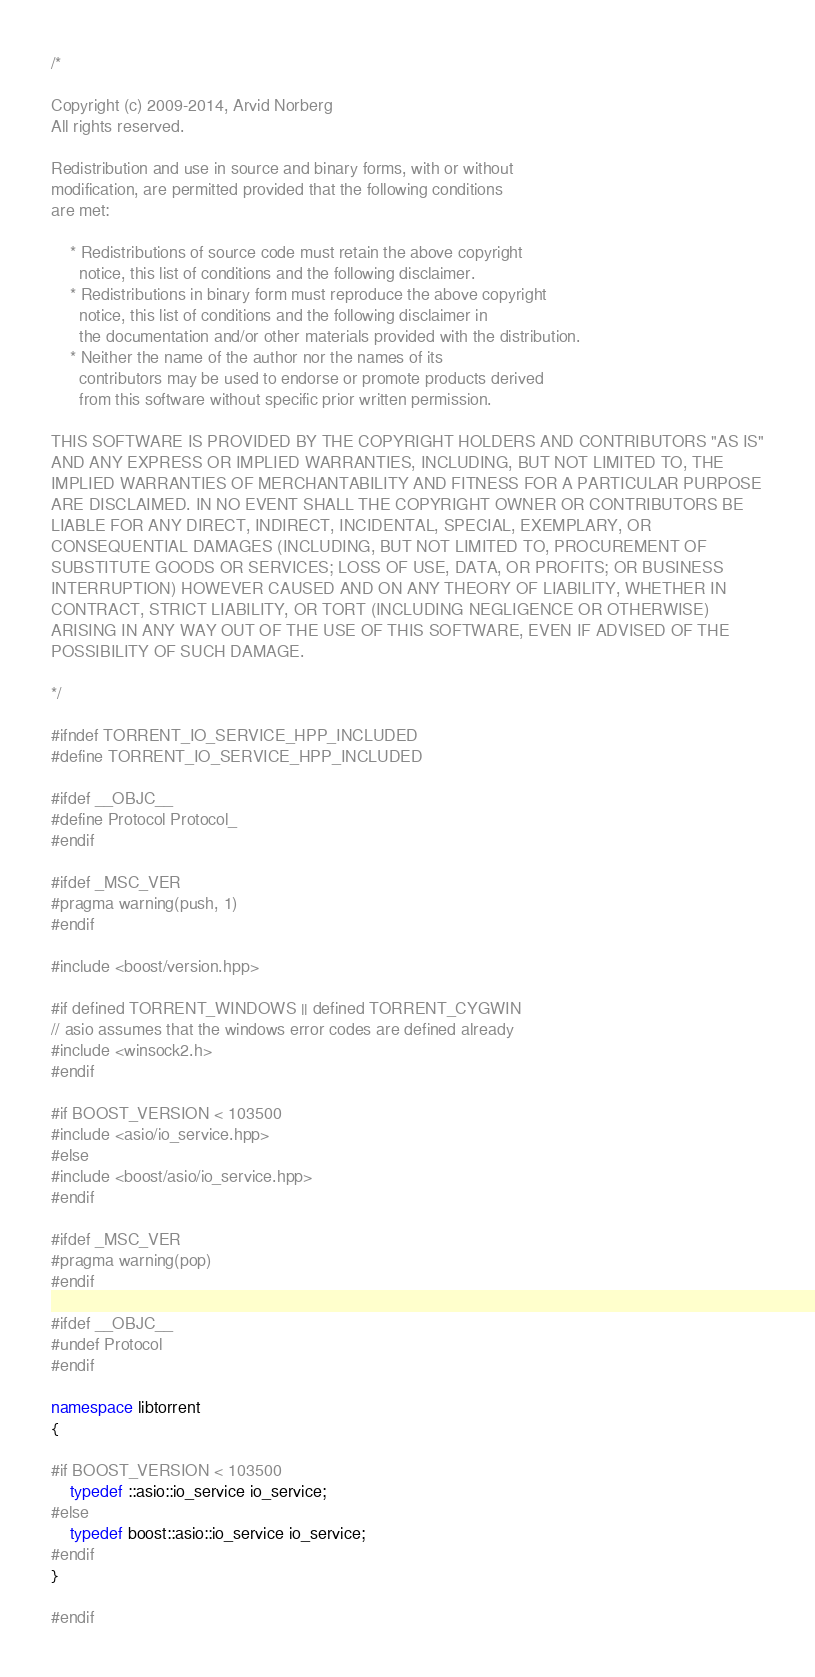Convert code to text. <code><loc_0><loc_0><loc_500><loc_500><_C++_>/*

Copyright (c) 2009-2014, Arvid Norberg
All rights reserved.

Redistribution and use in source and binary forms, with or without
modification, are permitted provided that the following conditions
are met:

    * Redistributions of source code must retain the above copyright
      notice, this list of conditions and the following disclaimer.
    * Redistributions in binary form must reproduce the above copyright
      notice, this list of conditions and the following disclaimer in
      the documentation and/or other materials provided with the distribution.
    * Neither the name of the author nor the names of its
      contributors may be used to endorse or promote products derived
      from this software without specific prior written permission.

THIS SOFTWARE IS PROVIDED BY THE COPYRIGHT HOLDERS AND CONTRIBUTORS "AS IS"
AND ANY EXPRESS OR IMPLIED WARRANTIES, INCLUDING, BUT NOT LIMITED TO, THE
IMPLIED WARRANTIES OF MERCHANTABILITY AND FITNESS FOR A PARTICULAR PURPOSE
ARE DISCLAIMED. IN NO EVENT SHALL THE COPYRIGHT OWNER OR CONTRIBUTORS BE
LIABLE FOR ANY DIRECT, INDIRECT, INCIDENTAL, SPECIAL, EXEMPLARY, OR
CONSEQUENTIAL DAMAGES (INCLUDING, BUT NOT LIMITED TO, PROCUREMENT OF
SUBSTITUTE GOODS OR SERVICES; LOSS OF USE, DATA, OR PROFITS; OR BUSINESS
INTERRUPTION) HOWEVER CAUSED AND ON ANY THEORY OF LIABILITY, WHETHER IN
CONTRACT, STRICT LIABILITY, OR TORT (INCLUDING NEGLIGENCE OR OTHERWISE)
ARISING IN ANY WAY OUT OF THE USE OF THIS SOFTWARE, EVEN IF ADVISED OF THE
POSSIBILITY OF SUCH DAMAGE.

*/

#ifndef TORRENT_IO_SERVICE_HPP_INCLUDED
#define TORRENT_IO_SERVICE_HPP_INCLUDED

#ifdef __OBJC__
#define Protocol Protocol_
#endif

#ifdef _MSC_VER
#pragma warning(push, 1)
#endif

#include <boost/version.hpp>

#if defined TORRENT_WINDOWS || defined TORRENT_CYGWIN
// asio assumes that the windows error codes are defined already
#include <winsock2.h>
#endif

#if BOOST_VERSION < 103500
#include <asio/io_service.hpp>
#else
#include <boost/asio/io_service.hpp>
#endif

#ifdef _MSC_VER
#pragma warning(pop)
#endif

#ifdef __OBJC__ 
#undef Protocol
#endif

namespace libtorrent
{

#if BOOST_VERSION < 103500
	typedef ::asio::io_service io_service;
#else
	typedef boost::asio::io_service io_service;
#endif
}

#endif


</code> 